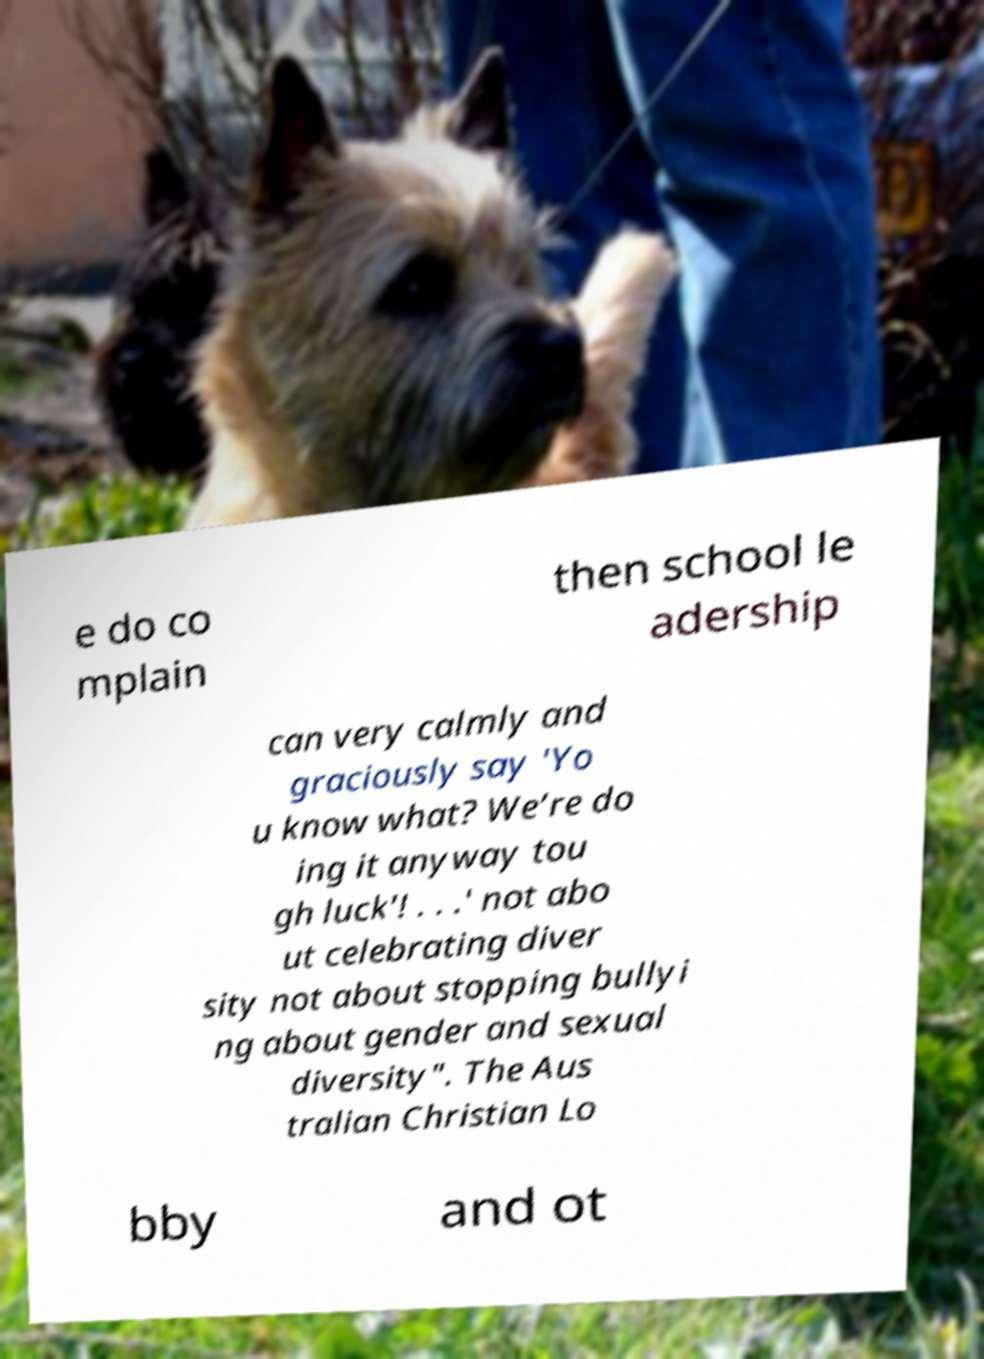For documentation purposes, I need the text within this image transcribed. Could you provide that? e do co mplain then school le adership can very calmly and graciously say 'Yo u know what? We’re do ing it anyway tou gh luck'! . . .' not abo ut celebrating diver sity not about stopping bullyi ng about gender and sexual diversity". The Aus tralian Christian Lo bby and ot 